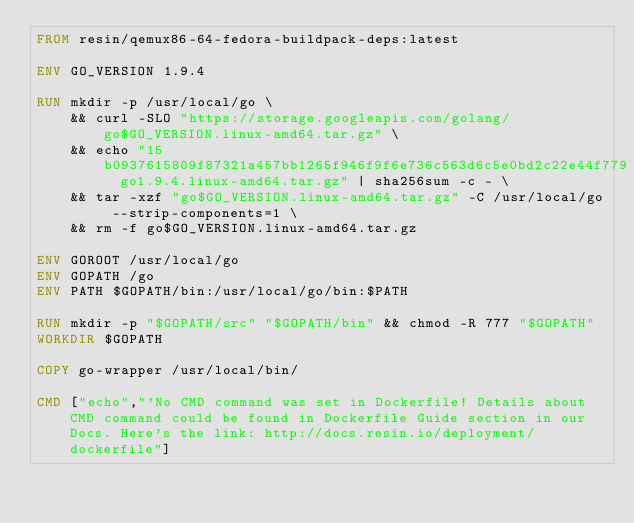Convert code to text. <code><loc_0><loc_0><loc_500><loc_500><_Dockerfile_>FROM resin/qemux86-64-fedora-buildpack-deps:latest

ENV GO_VERSION 1.9.4

RUN mkdir -p /usr/local/go \
	&& curl -SLO "https://storage.googleapis.com/golang/go$GO_VERSION.linux-amd64.tar.gz" \
	&& echo "15b0937615809f87321a457bb1265f946f9f6e736c563d6c5e0bd2c22e44f779  go1.9.4.linux-amd64.tar.gz" | sha256sum -c - \
	&& tar -xzf "go$GO_VERSION.linux-amd64.tar.gz" -C /usr/local/go --strip-components=1 \
	&& rm -f go$GO_VERSION.linux-amd64.tar.gz

ENV GOROOT /usr/local/go
ENV GOPATH /go
ENV PATH $GOPATH/bin:/usr/local/go/bin:$PATH

RUN mkdir -p "$GOPATH/src" "$GOPATH/bin" && chmod -R 777 "$GOPATH"
WORKDIR $GOPATH

COPY go-wrapper /usr/local/bin/

CMD ["echo","'No CMD command was set in Dockerfile! Details about CMD command could be found in Dockerfile Guide section in our Docs. Here's the link: http://docs.resin.io/deployment/dockerfile"]
</code> 